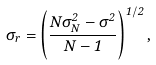Convert formula to latex. <formula><loc_0><loc_0><loc_500><loc_500>\sigma _ { r } = \left ( \frac { N \sigma _ { N } ^ { 2 } - \sigma ^ { 2 } } { N - 1 } \right ) ^ { 1 / 2 } ,</formula> 